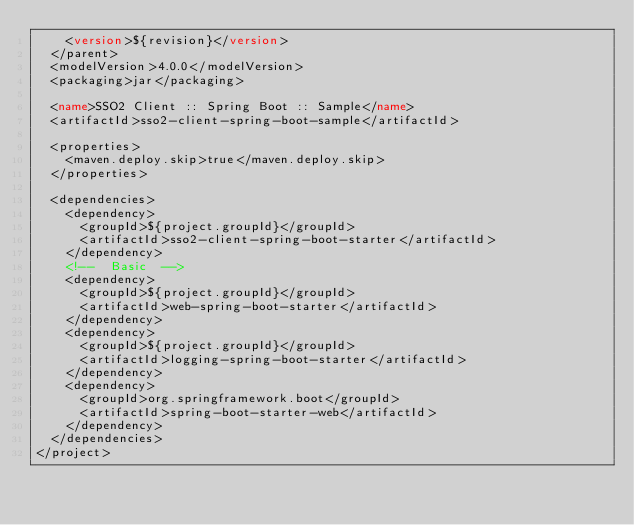<code> <loc_0><loc_0><loc_500><loc_500><_XML_>    <version>${revision}</version>
  </parent>
  <modelVersion>4.0.0</modelVersion>
  <packaging>jar</packaging>

  <name>SSO2 Client :: Spring Boot :: Sample</name>
  <artifactId>sso2-client-spring-boot-sample</artifactId>

  <properties>
    <maven.deploy.skip>true</maven.deploy.skip>
  </properties>

  <dependencies>
    <dependency>
      <groupId>${project.groupId}</groupId>
      <artifactId>sso2-client-spring-boot-starter</artifactId>
    </dependency>
    <!--  Basic  -->
    <dependency>
      <groupId>${project.groupId}</groupId>
      <artifactId>web-spring-boot-starter</artifactId>
    </dependency>
    <dependency>
      <groupId>${project.groupId}</groupId>
      <artifactId>logging-spring-boot-starter</artifactId>
    </dependency>
    <dependency>
      <groupId>org.springframework.boot</groupId>
      <artifactId>spring-boot-starter-web</artifactId>
    </dependency>
  </dependencies>
</project>
</code> 